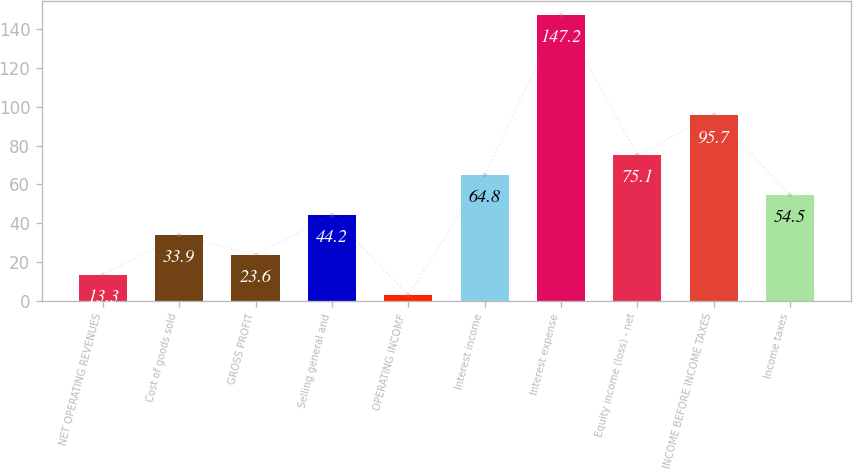<chart> <loc_0><loc_0><loc_500><loc_500><bar_chart><fcel>NET OPERATING REVENUES<fcel>Cost of goods sold<fcel>GROSS PROFIT<fcel>Selling general and<fcel>OPERATING INCOME<fcel>Interest income<fcel>Interest expense<fcel>Equity income (loss) - net<fcel>INCOME BEFORE INCOME TAXES<fcel>Income taxes<nl><fcel>13.3<fcel>33.9<fcel>23.6<fcel>44.2<fcel>3<fcel>64.8<fcel>147.2<fcel>75.1<fcel>95.7<fcel>54.5<nl></chart> 